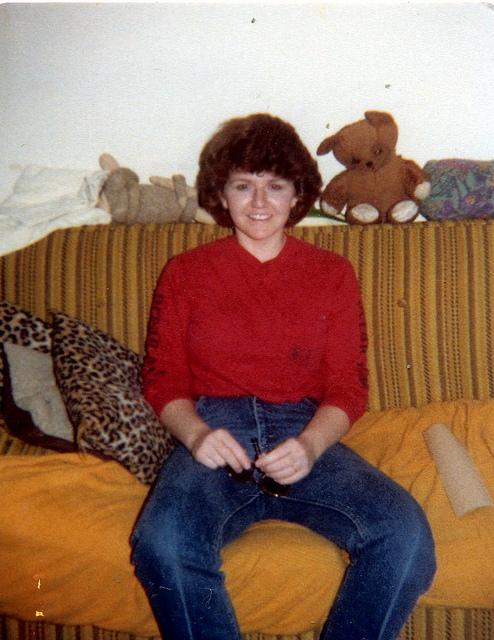Are there stuffed animals on the back of the couch?
Keep it brief. Yes. Is this picture taken recently?
Write a very short answer. No. What color is the couch?
Write a very short answer. Orange. 